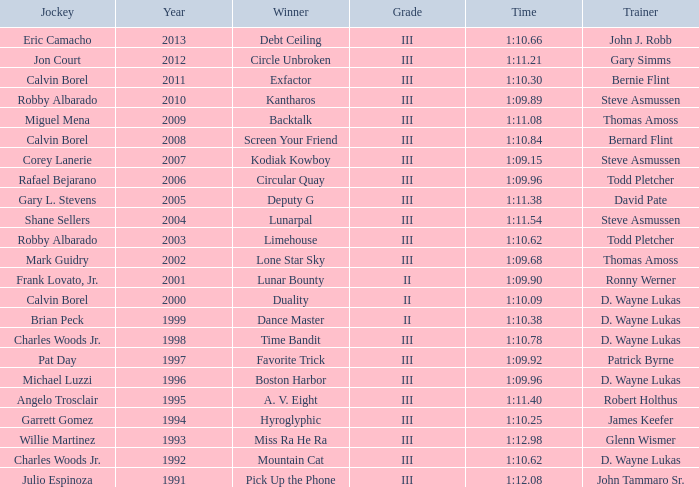Who won under Gary Simms? Circle Unbroken. 